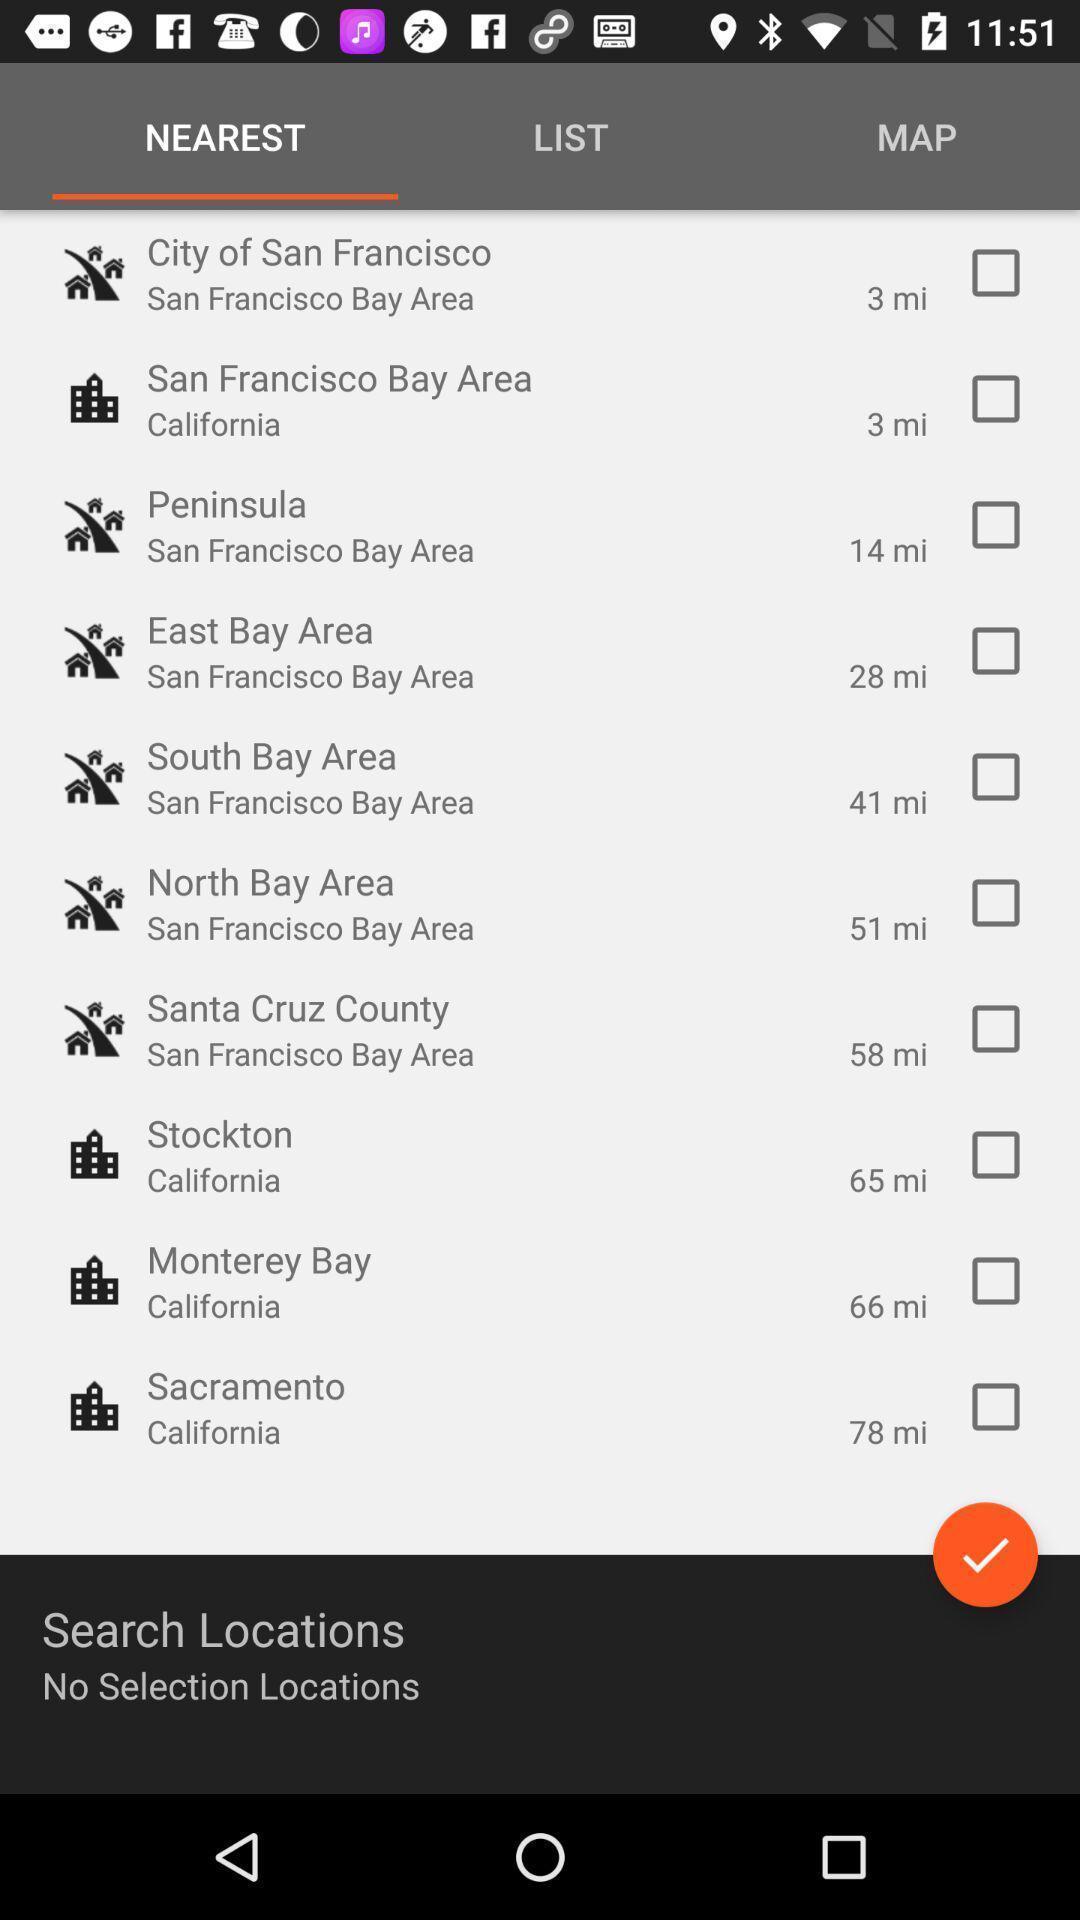Describe the content in this image. Page displaying different options. 